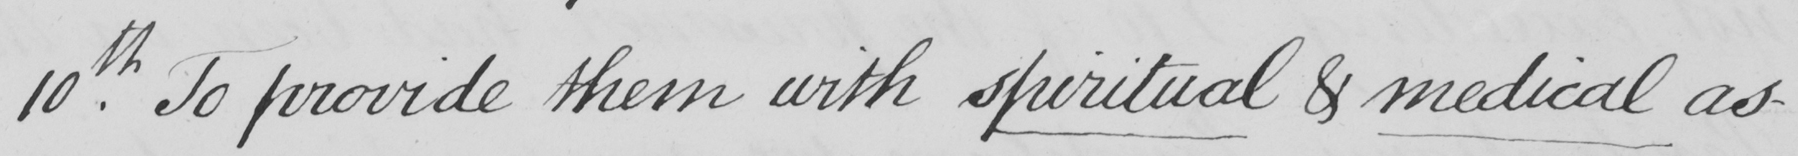Can you tell me what this handwritten text says? 10th . To provide them with spiritual & medical as- 